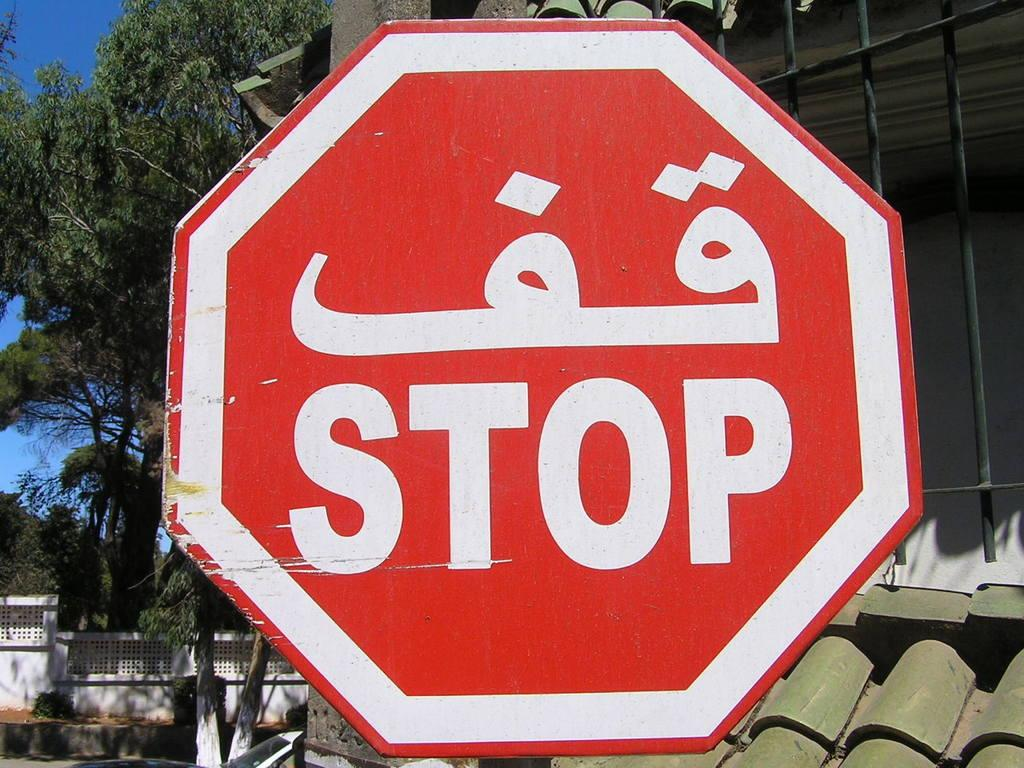What is the color of the stop board in the image? The stop board in the image is red-colored. What is the color of the roof in the image? The roof in the image is green-colored. What is the color of the railing in the image? The railing in the image is black-colored. What can be seen in the background of the image? There are trees and a white-colored wall visible in the background of the image. What else is visible in the background of the image? The sky is visible in the background of the image. What type of fact can be seen on the flag in the image? There is no flag present in the image, so it is not possible to determine what type of fact might be seen on it. 